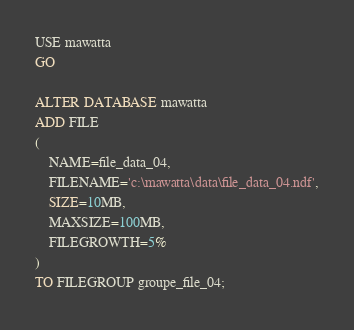<code> <loc_0><loc_0><loc_500><loc_500><_SQL_>USE mawatta
GO

ALTER DATABASE mawatta
ADD FILE
(
	NAME=file_data_04,
	FILENAME='c:\mawatta\data\file_data_04.ndf',
	SIZE=10MB,
	MAXSIZE=100MB,
	FILEGROWTH=5%
)
TO FILEGROUP groupe_file_04;</code> 